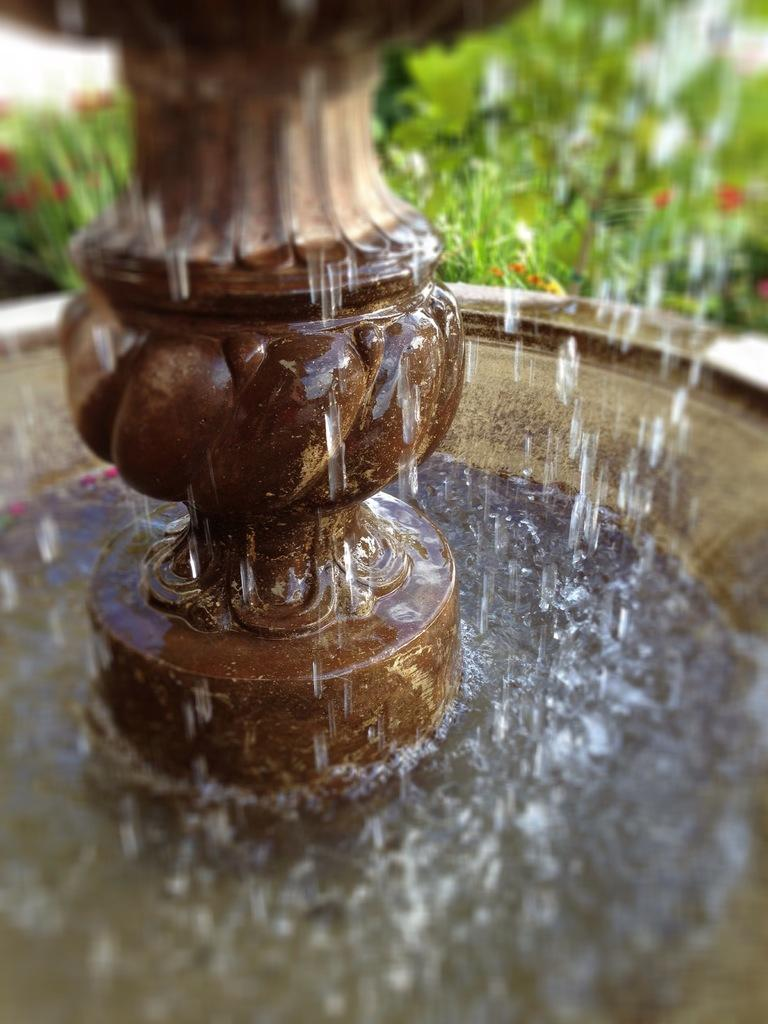What is the main feature in the image? There is a fountain in the image. What colors can be seen in the background of the image? There are flowers in red color and plants in green color in the background. What type of yarn is being used to create the fountain in the image? There is no yarn present in the image; the fountain is a water feature. 